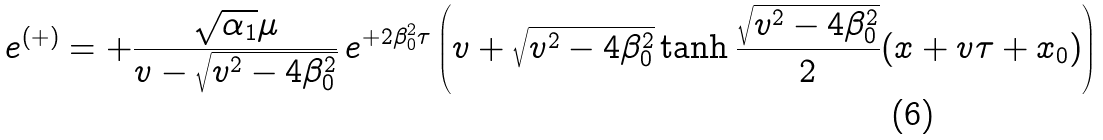Convert formula to latex. <formula><loc_0><loc_0><loc_500><loc_500>e ^ { ( + ) } = + \frac { \sqrt { \alpha _ { 1 } } \mu } { v - \sqrt { v ^ { 2 } - 4 \beta ^ { 2 } _ { 0 } } } \, e ^ { + 2 \beta ^ { 2 } _ { 0 } \tau } \left ( v + \sqrt { v ^ { 2 } - 4 \beta ^ { 2 } _ { 0 } } \tanh \frac { \sqrt { v ^ { 2 } - 4 \beta ^ { 2 } _ { 0 } } } { 2 } ( x + v \tau + x _ { 0 } ) \right )</formula> 